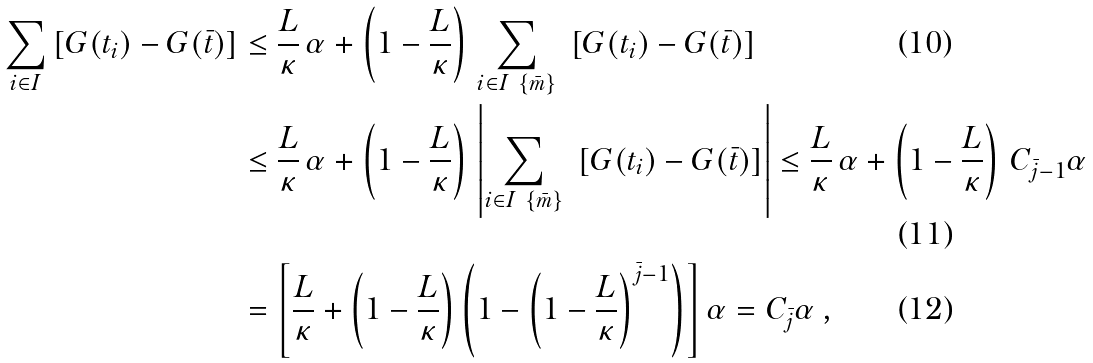<formula> <loc_0><loc_0><loc_500><loc_500>\sum _ { i \in I } \left [ G ( t _ { i } ) - G ( \bar { t } ) \right ] & \leq \frac { L } { \kappa } \, \alpha + \left ( 1 - \frac { L } { \kappa } \right ) \, \sum _ { i \in I \ \{ { \bar { m } } \} } \ \left [ G ( t _ { i } ) - G ( \bar { t } ) \right ] \\ & \leq \frac { L } { \kappa } \, \alpha + \left ( 1 - \frac { L } { \kappa } \right ) \, \left | \sum _ { i \in I \ \{ { \bar { m } } \} } \ \left [ G ( t _ { i } ) - G ( \bar { t } ) \right ] \right | \leq \frac { L } { \kappa } \, \alpha + \left ( 1 - \frac { L } { \kappa } \right ) \, C _ { \bar { j } - 1 } \alpha \\ & = \left [ \frac { L } { \kappa } + \left ( 1 - \frac { L } { \kappa } \right ) \left ( 1 - \left ( 1 - \frac { L } { \kappa } \right ) ^ { \bar { j } - 1 } \right ) \right ] \alpha = C _ { \bar { j } } \alpha \, ,</formula> 